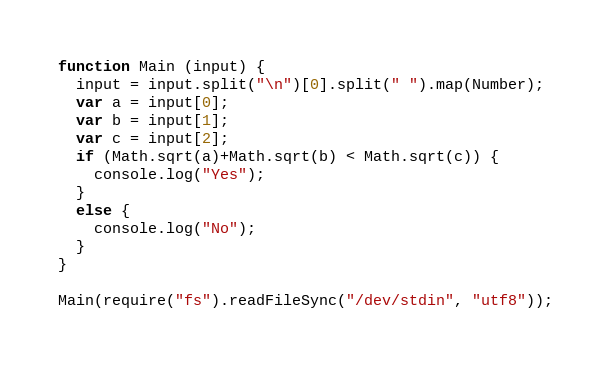Convert code to text. <code><loc_0><loc_0><loc_500><loc_500><_JavaScript_>function Main (input) {
  input = input.split("\n")[0].split(" ").map(Number);
  var a = input[0];
  var b = input[1];
  var c = input[2];
  if (Math.sqrt(a)+Math.sqrt(b) < Math.sqrt(c)) {
    console.log("Yes");
  }
  else {
    console.log("No");
  }
}

Main(require("fs").readFileSync("/dev/stdin", "utf8"));</code> 